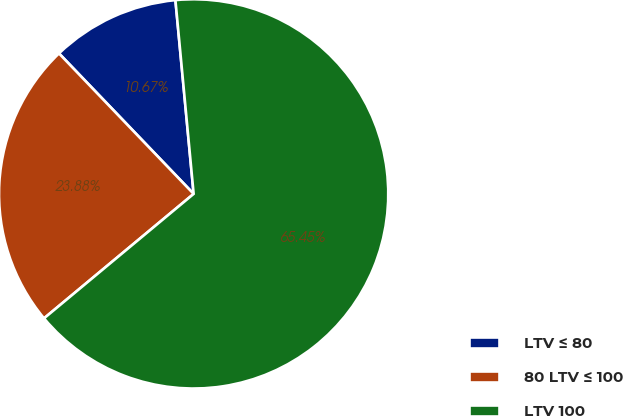Convert chart. <chart><loc_0><loc_0><loc_500><loc_500><pie_chart><fcel>LTV ≤ 80<fcel>80 LTV ≤ 100<fcel>LTV 100<nl><fcel>10.67%<fcel>23.88%<fcel>65.45%<nl></chart> 